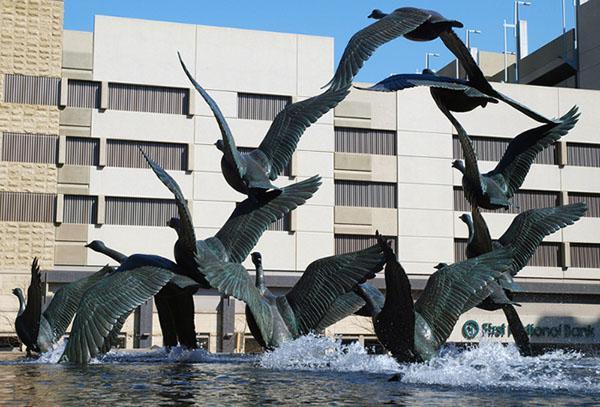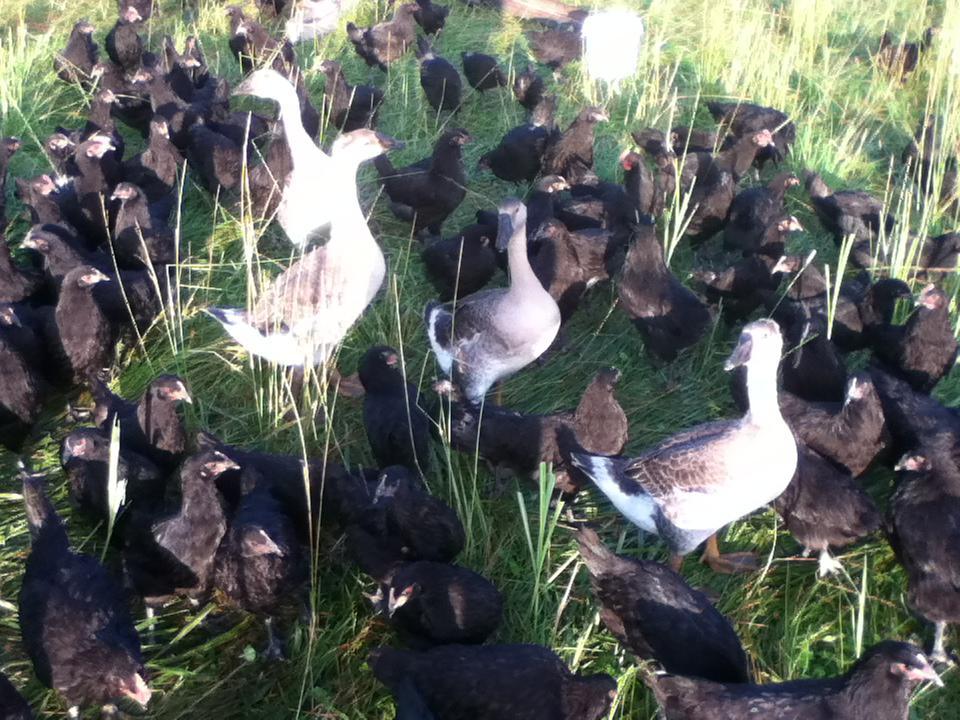The first image is the image on the left, the second image is the image on the right. Given the left and right images, does the statement "At least one goose has a black neck and beak, and a grey body." hold true? Answer yes or no. No. The first image is the image on the left, the second image is the image on the right. Evaluate the accuracy of this statement regarding the images: "In at least one image there are Blacked becked birds touching the water.". Is it true? Answer yes or no. Yes. 